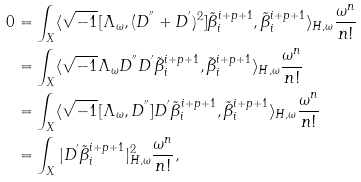Convert formula to latex. <formula><loc_0><loc_0><loc_500><loc_500>0 & = \int _ { X } \langle \sqrt { - 1 } [ \Lambda _ { \omega } , ( D ^ { ^ { \prime \prime } } + D ^ { ^ { \prime } } ) ^ { 2 } ] \tilde { \beta } _ { i } ^ { i + p + 1 } , \tilde { \beta } _ { i } ^ { i + p + 1 } \rangle _ { H , \omega } \frac { \omega ^ { n } } { n ! } \\ & = \int _ { X } \langle \sqrt { - 1 } \Lambda _ { \omega } D ^ { ^ { \prime \prime } } D ^ { ^ { \prime } } \tilde { \beta } _ { i } ^ { i + p + 1 } , \tilde { \beta } _ { i } ^ { i + p + 1 } \rangle _ { H , \omega } \frac { \omega ^ { n } } { n ! } \\ & = \int _ { X } \langle \sqrt { - 1 } [ \Lambda _ { \omega } , D ^ { ^ { \prime \prime } } ] D ^ { ^ { \prime } } \tilde { \beta } _ { i } ^ { i + p + 1 } , \tilde { \beta } _ { i } ^ { i + p + 1 } \rangle _ { H , \omega } \frac { \omega ^ { n } } { n ! } \\ & = \int _ { X } | D ^ { ^ { \prime } } \tilde { \beta } _ { i } ^ { i + p + 1 } | ^ { 2 } _ { H , \omega } \frac { \omega ^ { n } } { n ! } ,</formula> 